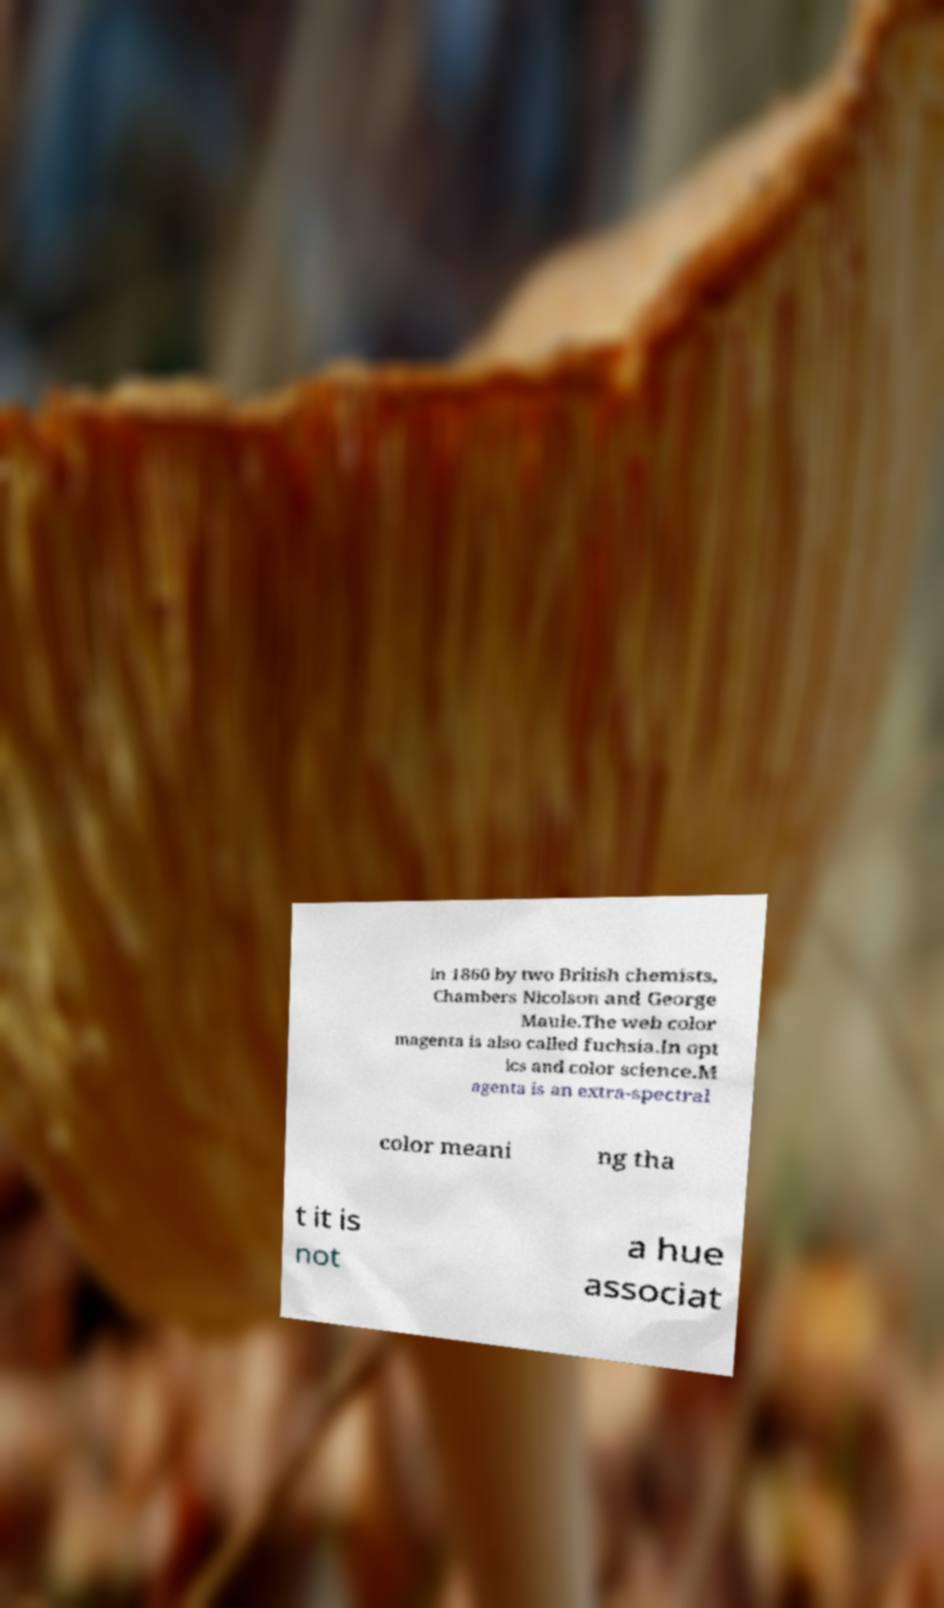Can you read and provide the text displayed in the image?This photo seems to have some interesting text. Can you extract and type it out for me? in 1860 by two British chemists, Chambers Nicolson and George Maule.The web color magenta is also called fuchsia.In opt ics and color science.M agenta is an extra-spectral color meani ng tha t it is not a hue associat 